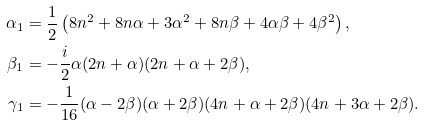<formula> <loc_0><loc_0><loc_500><loc_500>\alpha _ { 1 } & = \frac { 1 } { 2 } \left ( 8 n ^ { 2 } + 8 n \alpha + 3 \alpha ^ { 2 } + 8 n \beta + 4 \alpha \beta + 4 \beta ^ { 2 } \right ) , \\ \beta _ { 1 } & = - \frac { i } { 2 } \alpha ( 2 n + \alpha ) ( 2 n + \alpha + 2 \beta ) , \\ \gamma _ { 1 } & = - \frac { 1 } { 1 6 } ( \alpha - 2 \beta ) ( \alpha + 2 \beta ) ( 4 n + \alpha + 2 \beta ) ( 4 n + 3 \alpha + 2 \beta ) .</formula> 